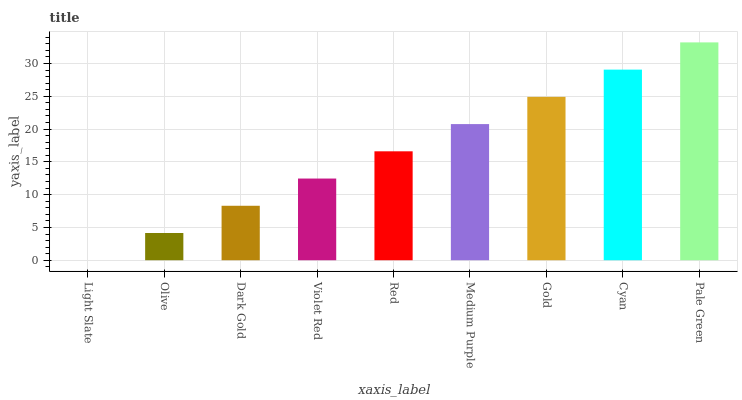Is Olive the minimum?
Answer yes or no. No. Is Olive the maximum?
Answer yes or no. No. Is Olive greater than Light Slate?
Answer yes or no. Yes. Is Light Slate less than Olive?
Answer yes or no. Yes. Is Light Slate greater than Olive?
Answer yes or no. No. Is Olive less than Light Slate?
Answer yes or no. No. Is Red the high median?
Answer yes or no. Yes. Is Red the low median?
Answer yes or no. Yes. Is Dark Gold the high median?
Answer yes or no. No. Is Olive the low median?
Answer yes or no. No. 